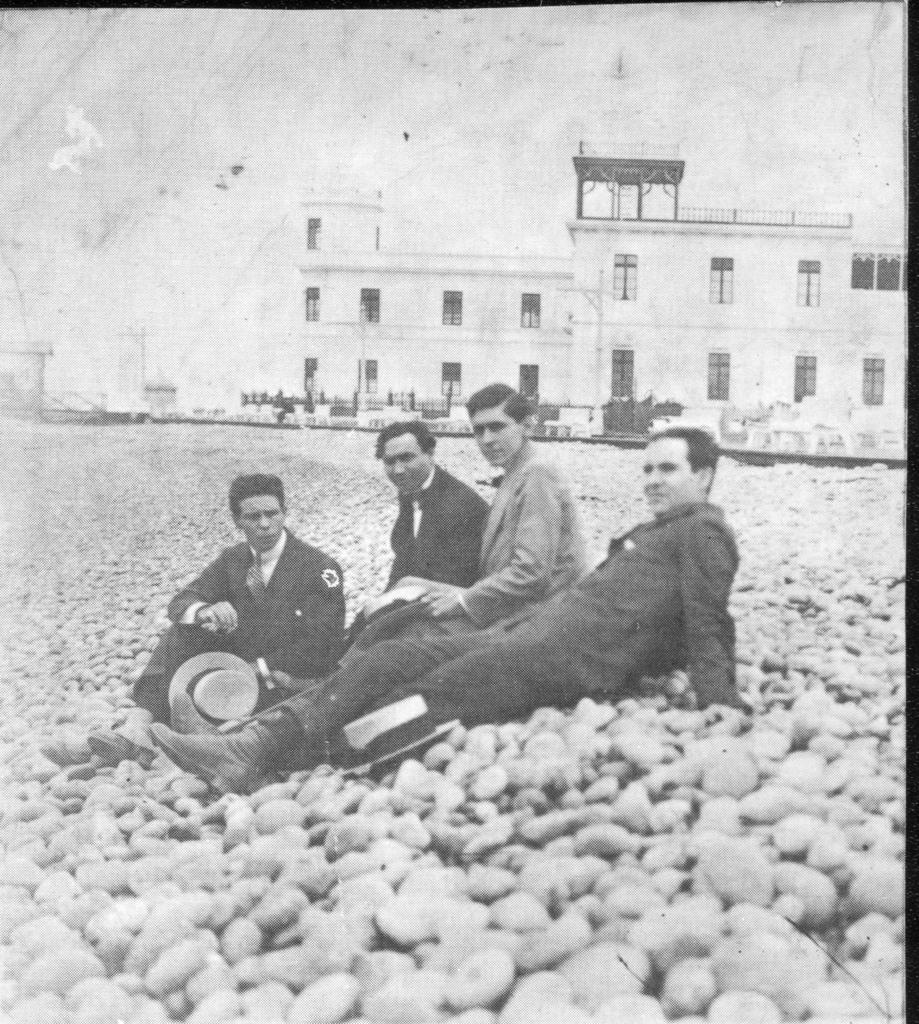Could you give a brief overview of what you see in this image? This is a black and white image. In the foreground of the picture there are four men sitting on the stones. In the background there are buildings, trees and road. Sky is cloudy. 